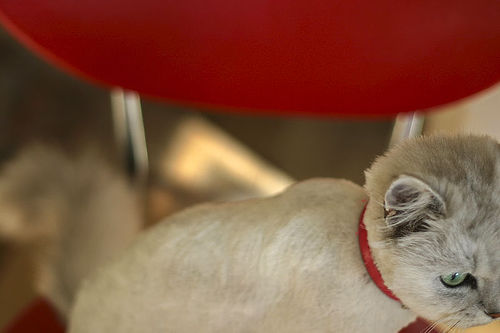<image>Where is the red plate? It is ambiguous where the red plate is located. It is either not in the image or it could be behind or above the cat. Where is the red plate? There is no red plate in the image. 